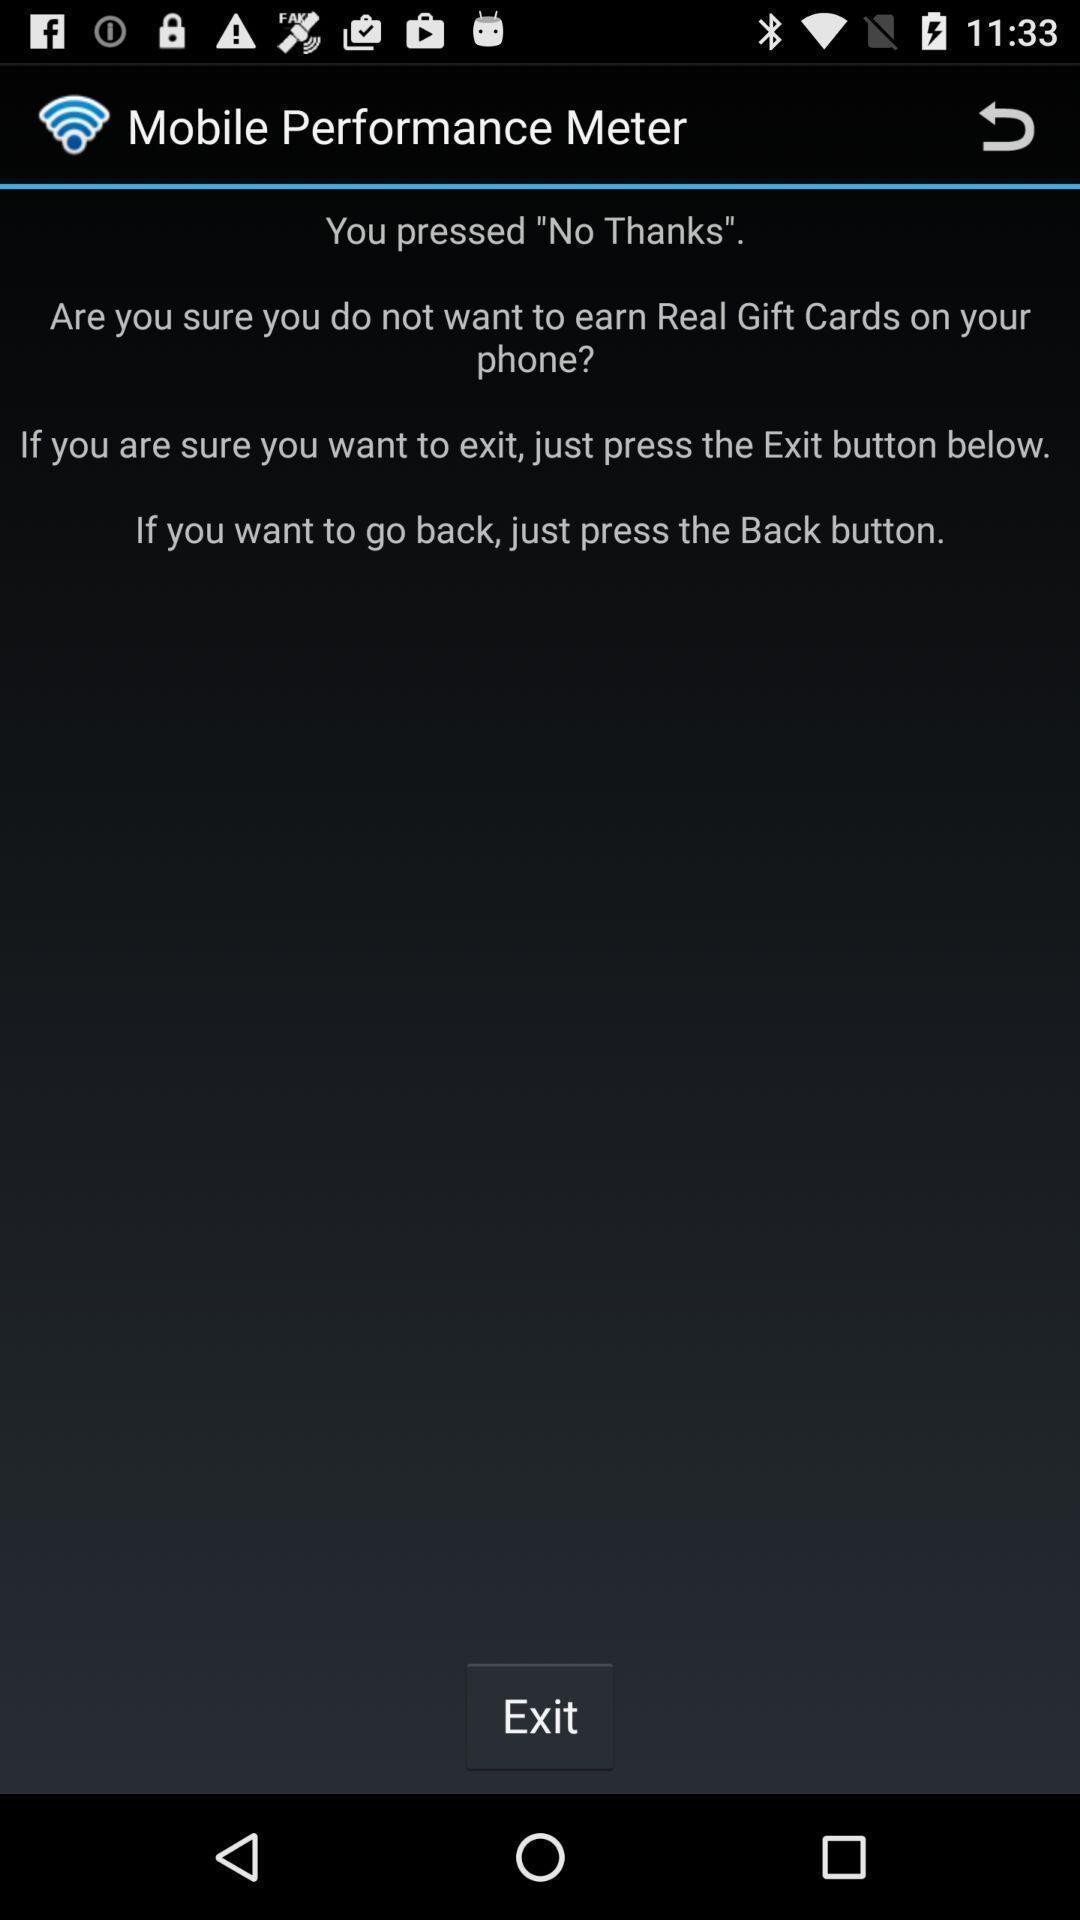Explain the elements present in this screenshot. Page showing information and instruction about app. 